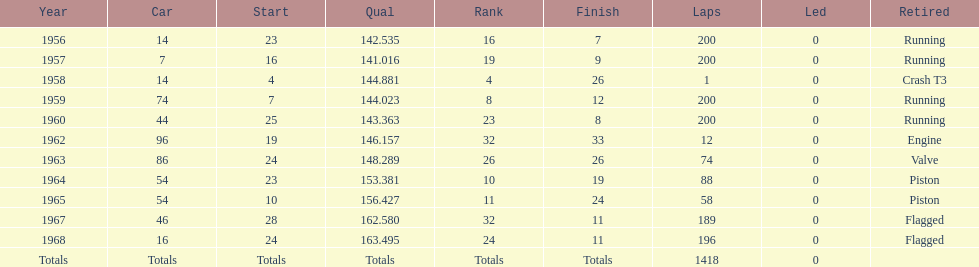What was the length of time bob veith had the number 54 car in indy 500? 2 years. 